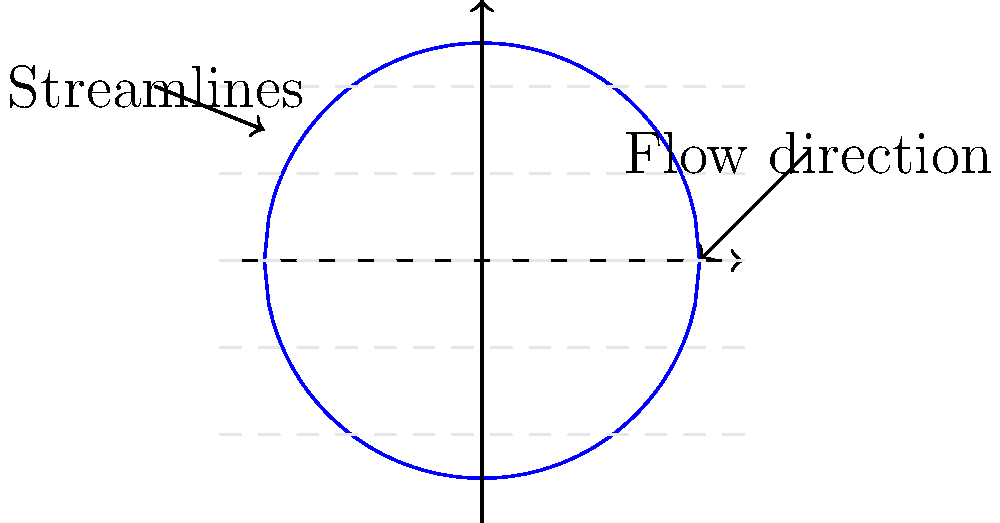As a former war journalist who has observed various aerial operations, consider the fluid flow patterns around a cylindrical object, such as those encountered in aircraft design. Based on the streamline diagram shown, what phenomenon is likely to occur in the region immediately behind the cylinder, and how might this affect the performance of an aircraft or drone in a conflict zone? To answer this question, let's analyze the fluid flow patterns step-by-step:

1. The diagram shows streamlines around a circular cross-section, representing a cylinder.

2. The streamlines are symmetrical above and below the cylinder, indicating uniform flow upstream.

3. As the fluid approaches the cylinder, the streamlines diverge and flow around it.

4. Behind the cylinder, we observe that the streamlines do not immediately converge.

5. This gap in the streamlines behind the cylinder indicates a region of separated flow, known as the wake.

6. In this wake region, several phenomena occur:
   a) Low-pressure area forms
   b) Flow reversal and recirculation may happen
   c) Vortices can develop

7. The wake region contributes to form drag, also known as pressure drag.

8. For aircraft or drones in a conflict zone:
   a) Increased drag reduces fuel efficiency and range
   b) Vortices in the wake can affect stability and control
   c) The low-pressure area can impact sensor performance or payload delivery

9. The phenomenon occurring in this region is called flow separation.

10. Flow separation leads to increased drag and reduced lift, which are critical factors in aircraft performance.

In conflict zones, where fuel efficiency, maneuverability, and stealth are crucial, understanding and minimizing flow separation is essential for effective aerial operations.
Answer: Flow separation, leading to increased drag and reduced performance. 